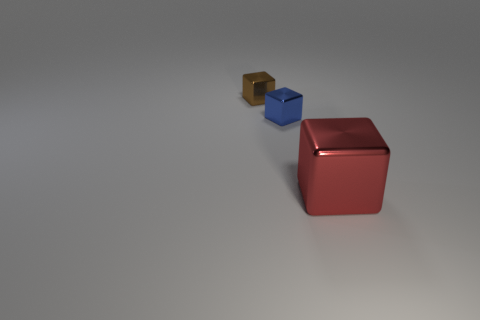Add 3 large metallic cubes. How many objects exist? 6 Add 1 small yellow matte objects. How many small yellow matte objects exist? 1 Subtract 0 brown cylinders. How many objects are left? 3 Subtract all small brown cubes. Subtract all metallic cylinders. How many objects are left? 2 Add 1 tiny brown blocks. How many tiny brown blocks are left? 2 